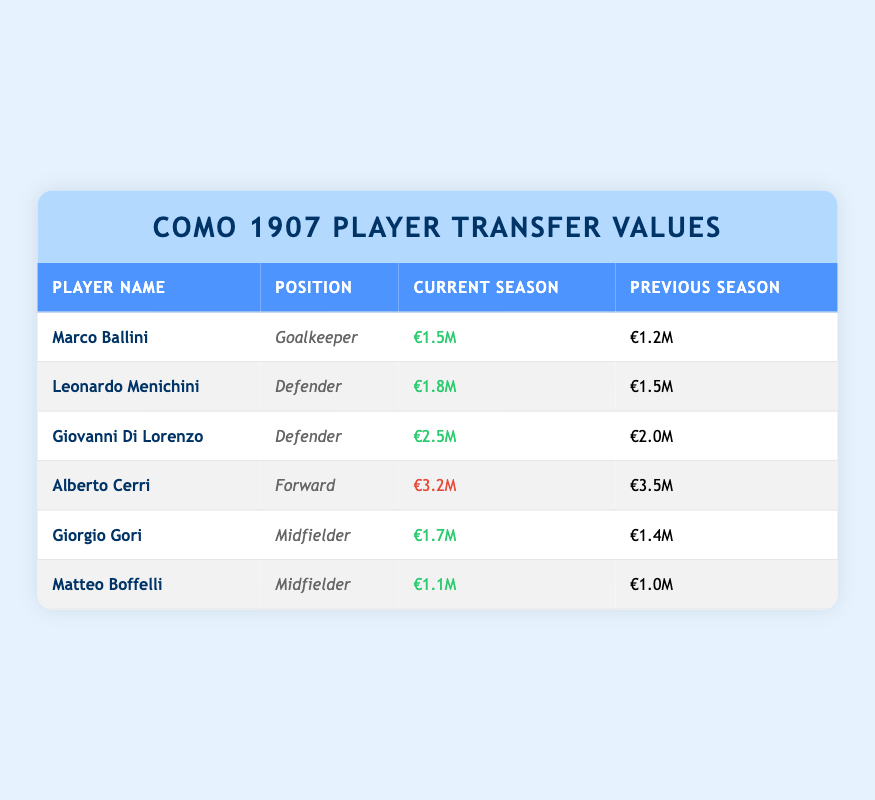What is the market value of Marco Ballini for the current season? The market value of Marco Ballini in the current season is listed directly in the table under "Market Value Current Season," which states €1.5M.
Answer: €1.5M Which player had the highest market value in the previous season? To find this, we look at the "Market Value Previous Season" column and identify the highest value among all players. Alberto Cerri has the highest market value at €3.5M.
Answer: €3.5M What is the total market value for all players in the current season? First, we gather the current season values: €1.5M + €1.8M + €2.5M + €3.2M + €1.7M + €1.1M = €12.8M. Therefore, the total market value for all players in the current season is €12.8M.
Answer: €12.8M Did any player see a decrease in market value from the previous season to the current season? By checking each player's current and previous values, we see that Alberto Cerri's value decreased from €3.5M to €3.2M. Therefore, yes, at least one player did experience a decrease.
Answer: Yes What is the average market value for midfielders in the current season? The midfielders are Giorgio Gori and Matteo Boffelli, with values of €1.7M and €1.1M respectively. The average is calculated as (€1.7M + €1.1M) / 2 = €1.4M. Hence, the average market value for midfielders is €1.4M.
Answer: €1.4M Which player increased their market value by the largest amount from the previous season to the current season? We calculate the changes for each player: Marco Ballini (+€0.3M), Leonardo Menichini (+€0.3M), Giovanni Di Lorenzo (+€0.5M), Alberto Cerri (-€0.3M), Giorgio Gori (+€0.3M), Matteo Boffelli (+€0.1M). The largest increase is for Giovanni Di Lorenzo with an increase of €0.5M.
Answer: Giovanni Di Lorenzo How many players have a current market value above €2M? By evaluating the "Market Value Current Season" column, we note that Giovanni Di Lorenzo (€2.5M) and Alberto Cerri (€3.2M) are the only players above €2M. In total, there are 2 players.
Answer: 2 Is there a midfielder who improved their market value from the previous season? We check the values of the midfielders: Giorgio Gori improved from €1.4M to €1.7M, and Matteo Boffelli improved from €1.0M to €1.1M. Therefore, both midfielders improved their market value.
Answer: Yes 